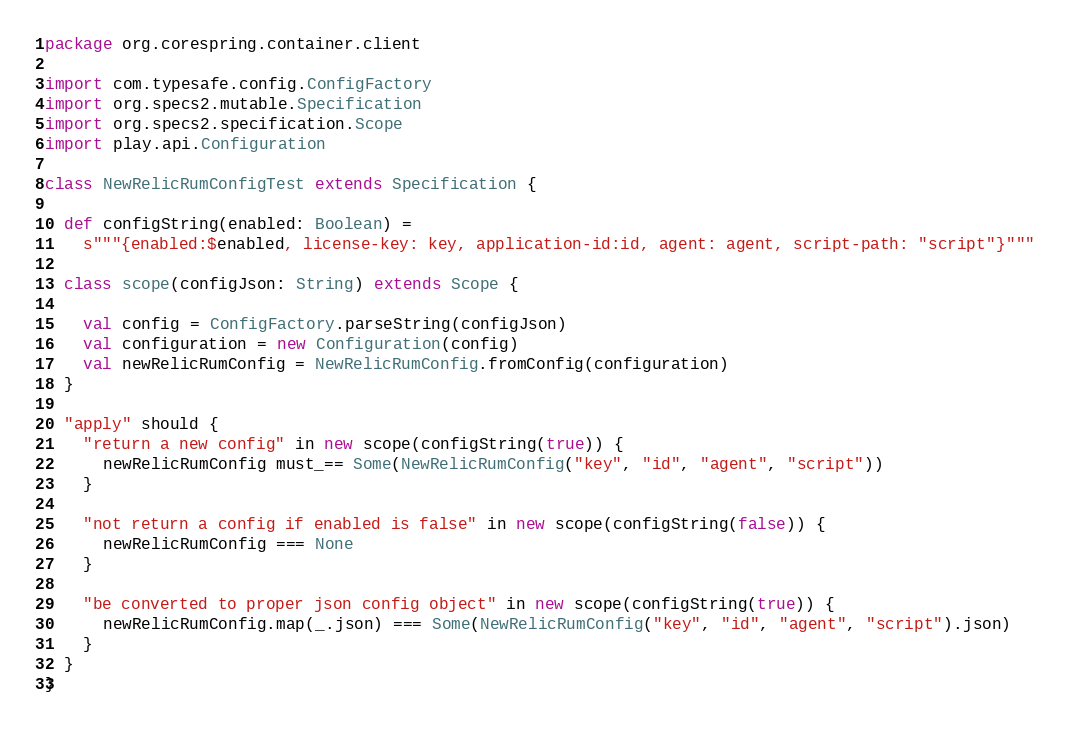<code> <loc_0><loc_0><loc_500><loc_500><_Scala_>package org.corespring.container.client

import com.typesafe.config.ConfigFactory
import org.specs2.mutable.Specification
import org.specs2.specification.Scope
import play.api.Configuration

class NewRelicRumConfigTest extends Specification {

  def configString(enabled: Boolean) =
    s"""{enabled:$enabled, license-key: key, application-id:id, agent: agent, script-path: "script"}"""

  class scope(configJson: String) extends Scope {

    val config = ConfigFactory.parseString(configJson)
    val configuration = new Configuration(config)
    val newRelicRumConfig = NewRelicRumConfig.fromConfig(configuration)
  }

  "apply" should {
    "return a new config" in new scope(configString(true)) {
      newRelicRumConfig must_== Some(NewRelicRumConfig("key", "id", "agent", "script"))
    }

    "not return a config if enabled is false" in new scope(configString(false)) {
      newRelicRumConfig === None
    }

    "be converted to proper json config object" in new scope(configString(true)) {
      newRelicRumConfig.map(_.json) === Some(NewRelicRumConfig("key", "id", "agent", "script").json)
    }
  }
}
</code> 